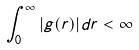Convert formula to latex. <formula><loc_0><loc_0><loc_500><loc_500>\int _ { 0 } ^ { \infty } | g ( r ) | d r < \infty</formula> 